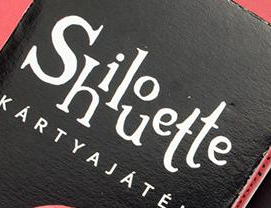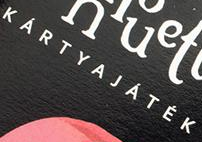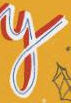What text is displayed in these images sequentially, separated by a semicolon? Shilouette; KÁRTYAJÁTÉK; y 